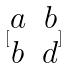Convert formula to latex. <formula><loc_0><loc_0><loc_500><loc_500>[ \begin{matrix} a & b \\ b & d \end{matrix} ]</formula> 